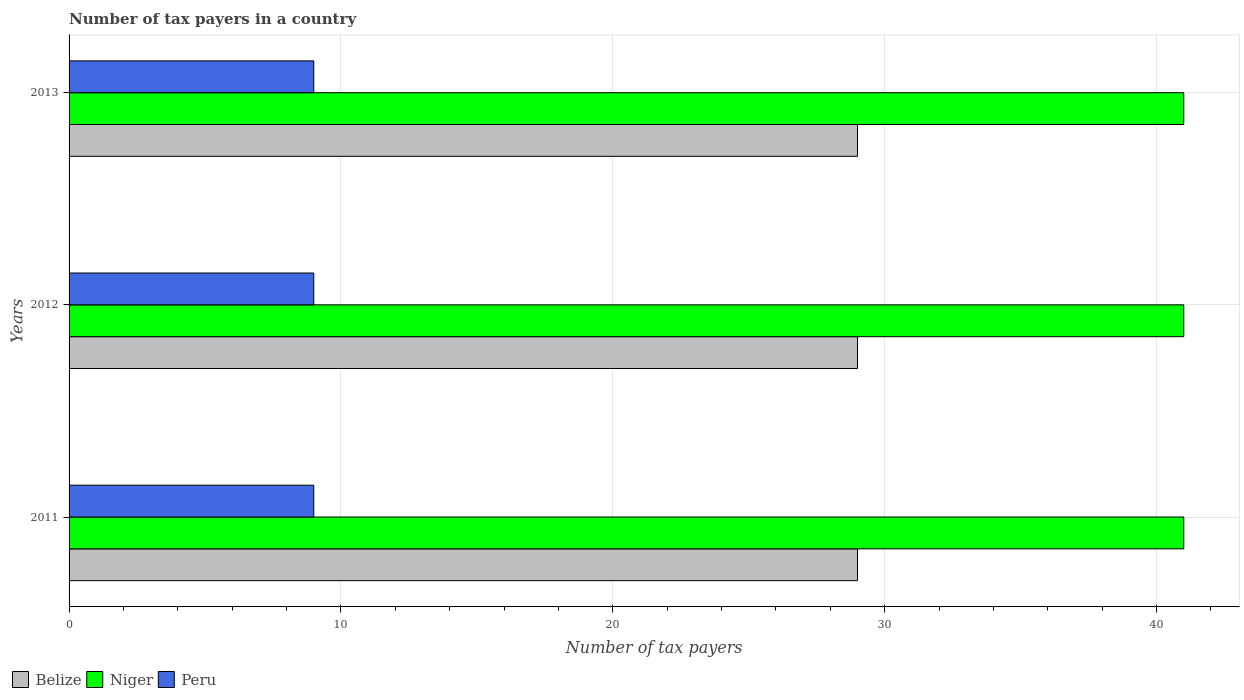How many different coloured bars are there?
Give a very brief answer. 3. Are the number of bars per tick equal to the number of legend labels?
Your answer should be compact. Yes. How many bars are there on the 1st tick from the bottom?
Give a very brief answer. 3. In how many cases, is the number of bars for a given year not equal to the number of legend labels?
Ensure brevity in your answer.  0. What is the number of tax payers in in Niger in 2013?
Give a very brief answer. 41. Across all years, what is the maximum number of tax payers in in Niger?
Offer a very short reply. 41. Across all years, what is the minimum number of tax payers in in Niger?
Your response must be concise. 41. In which year was the number of tax payers in in Belize minimum?
Offer a terse response. 2011. What is the total number of tax payers in in Belize in the graph?
Your answer should be very brief. 87. What is the difference between the number of tax payers in in Belize in 2011 and the number of tax payers in in Peru in 2012?
Your answer should be very brief. 20. What is the average number of tax payers in in Peru per year?
Ensure brevity in your answer.  9. In the year 2013, what is the difference between the number of tax payers in in Belize and number of tax payers in in Peru?
Ensure brevity in your answer.  20. In how many years, is the number of tax payers in in Niger greater than 12 ?
Your answer should be compact. 3. Is the number of tax payers in in Peru in 2011 less than that in 2013?
Provide a short and direct response. No. Is the difference between the number of tax payers in in Belize in 2011 and 2013 greater than the difference between the number of tax payers in in Peru in 2011 and 2013?
Your answer should be compact. No. What is the difference between the highest and the second highest number of tax payers in in Belize?
Give a very brief answer. 0. What is the difference between the highest and the lowest number of tax payers in in Niger?
Offer a very short reply. 0. Is the sum of the number of tax payers in in Peru in 2012 and 2013 greater than the maximum number of tax payers in in Belize across all years?
Your response must be concise. No. What does the 3rd bar from the top in 2011 represents?
Provide a short and direct response. Belize. What does the 1st bar from the bottom in 2013 represents?
Offer a very short reply. Belize. Are all the bars in the graph horizontal?
Keep it short and to the point. Yes. How many years are there in the graph?
Keep it short and to the point. 3. Are the values on the major ticks of X-axis written in scientific E-notation?
Your answer should be very brief. No. How many legend labels are there?
Give a very brief answer. 3. How are the legend labels stacked?
Give a very brief answer. Horizontal. What is the title of the graph?
Your response must be concise. Number of tax payers in a country. Does "Madagascar" appear as one of the legend labels in the graph?
Keep it short and to the point. No. What is the label or title of the X-axis?
Make the answer very short. Number of tax payers. What is the Number of tax payers in Belize in 2011?
Provide a succinct answer. 29. What is the Number of tax payers in Niger in 2011?
Make the answer very short. 41. What is the Number of tax payers of Peru in 2011?
Keep it short and to the point. 9. What is the Number of tax payers in Belize in 2012?
Your answer should be compact. 29. What is the Number of tax payers in Peru in 2012?
Your answer should be compact. 9. What is the Number of tax payers in Niger in 2013?
Provide a succinct answer. 41. What is the Number of tax payers of Peru in 2013?
Your response must be concise. 9. Across all years, what is the maximum Number of tax payers of Niger?
Offer a very short reply. 41. Across all years, what is the maximum Number of tax payers of Peru?
Ensure brevity in your answer.  9. Across all years, what is the minimum Number of tax payers of Niger?
Provide a succinct answer. 41. What is the total Number of tax payers of Belize in the graph?
Ensure brevity in your answer.  87. What is the total Number of tax payers of Niger in the graph?
Give a very brief answer. 123. What is the difference between the Number of tax payers of Belize in 2011 and that in 2012?
Keep it short and to the point. 0. What is the difference between the Number of tax payers of Belize in 2011 and that in 2013?
Offer a very short reply. 0. What is the difference between the Number of tax payers of Niger in 2011 and that in 2013?
Offer a very short reply. 0. What is the difference between the Number of tax payers of Niger in 2012 and that in 2013?
Make the answer very short. 0. What is the difference between the Number of tax payers in Peru in 2012 and that in 2013?
Your response must be concise. 0. What is the difference between the Number of tax payers of Belize in 2011 and the Number of tax payers of Niger in 2012?
Provide a succinct answer. -12. What is the difference between the Number of tax payers in Niger in 2011 and the Number of tax payers in Peru in 2012?
Provide a short and direct response. 32. What is the difference between the Number of tax payers of Belize in 2011 and the Number of tax payers of Niger in 2013?
Give a very brief answer. -12. What is the difference between the Number of tax payers of Belize in 2011 and the Number of tax payers of Peru in 2013?
Ensure brevity in your answer.  20. What is the average Number of tax payers of Belize per year?
Provide a succinct answer. 29. What is the average Number of tax payers of Niger per year?
Provide a succinct answer. 41. In the year 2011, what is the difference between the Number of tax payers in Belize and Number of tax payers in Niger?
Ensure brevity in your answer.  -12. In the year 2011, what is the difference between the Number of tax payers of Belize and Number of tax payers of Peru?
Ensure brevity in your answer.  20. In the year 2012, what is the difference between the Number of tax payers in Belize and Number of tax payers in Niger?
Ensure brevity in your answer.  -12. In the year 2012, what is the difference between the Number of tax payers of Belize and Number of tax payers of Peru?
Your answer should be compact. 20. In the year 2013, what is the difference between the Number of tax payers in Belize and Number of tax payers in Peru?
Ensure brevity in your answer.  20. In the year 2013, what is the difference between the Number of tax payers in Niger and Number of tax payers in Peru?
Offer a very short reply. 32. What is the ratio of the Number of tax payers in Belize in 2011 to that in 2012?
Ensure brevity in your answer.  1. What is the ratio of the Number of tax payers in Niger in 2011 to that in 2012?
Give a very brief answer. 1. What is the ratio of the Number of tax payers of Belize in 2011 to that in 2013?
Your answer should be very brief. 1. What is the ratio of the Number of tax payers in Niger in 2011 to that in 2013?
Provide a short and direct response. 1. What is the ratio of the Number of tax payers of Niger in 2012 to that in 2013?
Your answer should be compact. 1. What is the difference between the highest and the second highest Number of tax payers of Belize?
Make the answer very short. 0. What is the difference between the highest and the second highest Number of tax payers of Niger?
Ensure brevity in your answer.  0. What is the difference between the highest and the second highest Number of tax payers of Peru?
Provide a succinct answer. 0. What is the difference between the highest and the lowest Number of tax payers of Belize?
Offer a very short reply. 0. What is the difference between the highest and the lowest Number of tax payers in Niger?
Your answer should be compact. 0. 